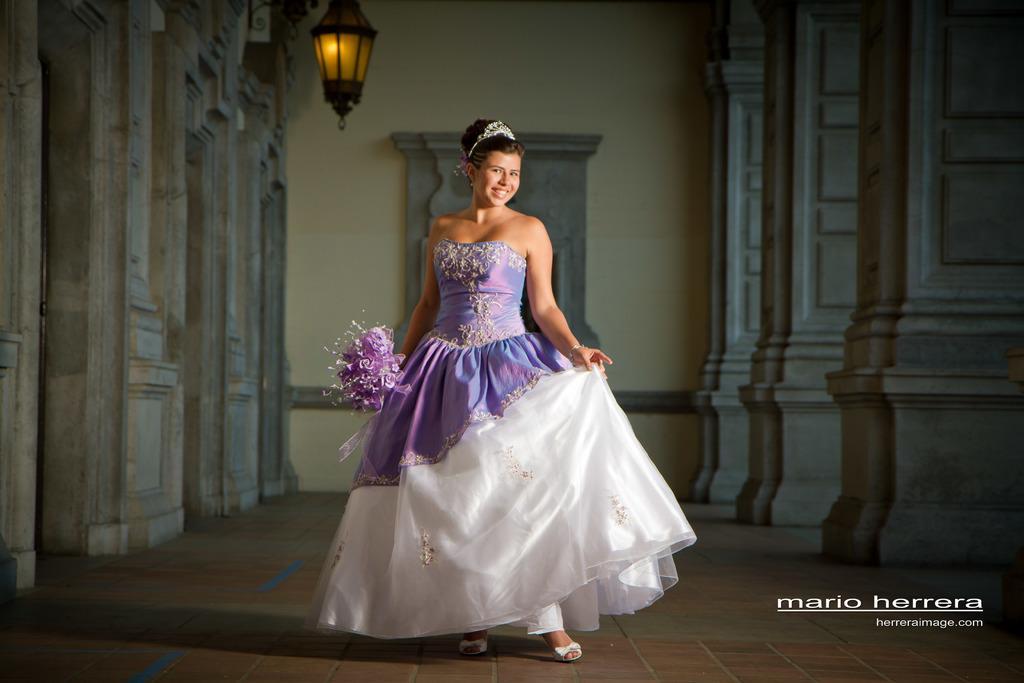Can you describe this image briefly? This picture is clicked inside the hall. In the center there is a woman wearing a dress, holding bouquet and seems to be standing on the ground. In the background we can see the wall, pillars and a lamp seems to be hanging. In the bottom right corner we can see the text on the image. 